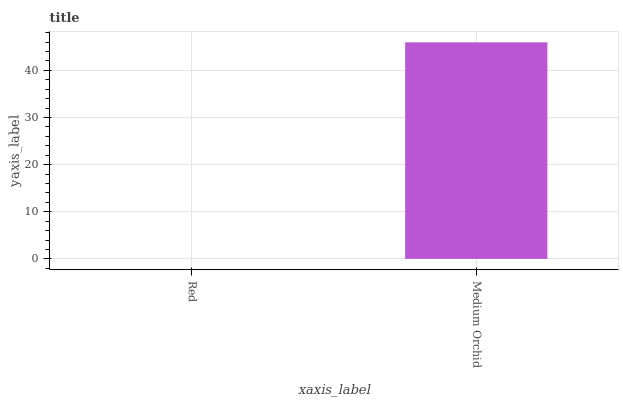Is Red the minimum?
Answer yes or no. Yes. Is Medium Orchid the maximum?
Answer yes or no. Yes. Is Medium Orchid the minimum?
Answer yes or no. No. Is Medium Orchid greater than Red?
Answer yes or no. Yes. Is Red less than Medium Orchid?
Answer yes or no. Yes. Is Red greater than Medium Orchid?
Answer yes or no. No. Is Medium Orchid less than Red?
Answer yes or no. No. Is Medium Orchid the high median?
Answer yes or no. Yes. Is Red the low median?
Answer yes or no. Yes. Is Red the high median?
Answer yes or no. No. Is Medium Orchid the low median?
Answer yes or no. No. 